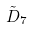Convert formula to latex. <formula><loc_0><loc_0><loc_500><loc_500>\tilde { D } _ { 7 }</formula> 